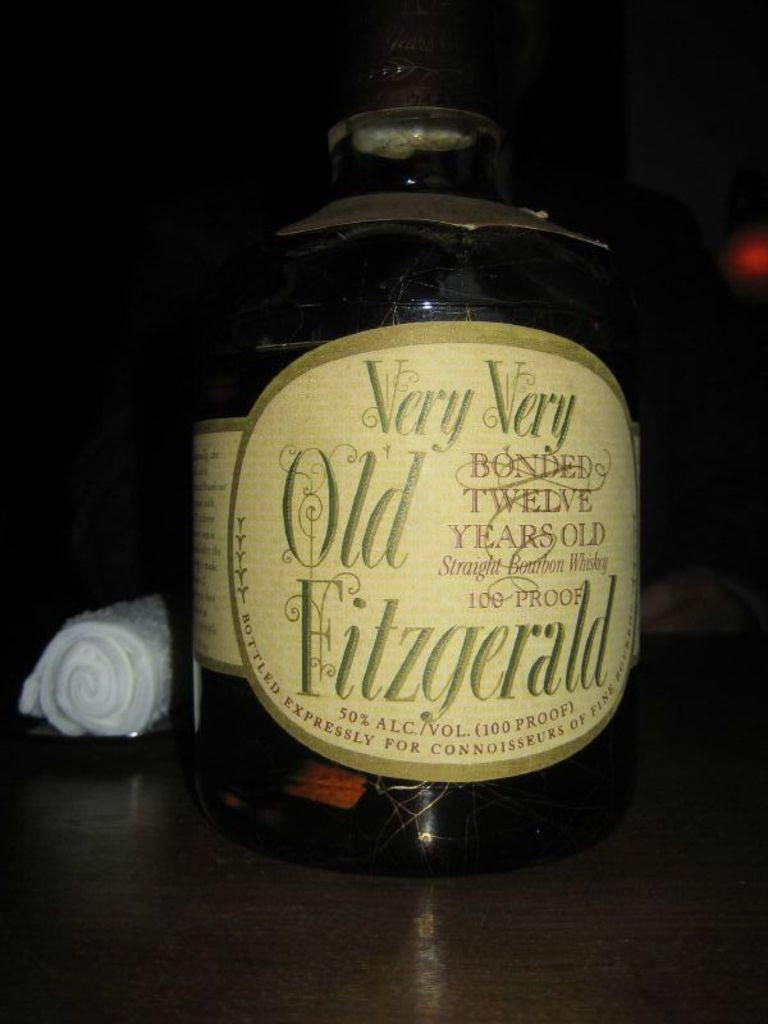<image>
Relay a brief, clear account of the picture shown. Very very old fitzgerald bourbon whisky bottle that is 50% alcohol. 